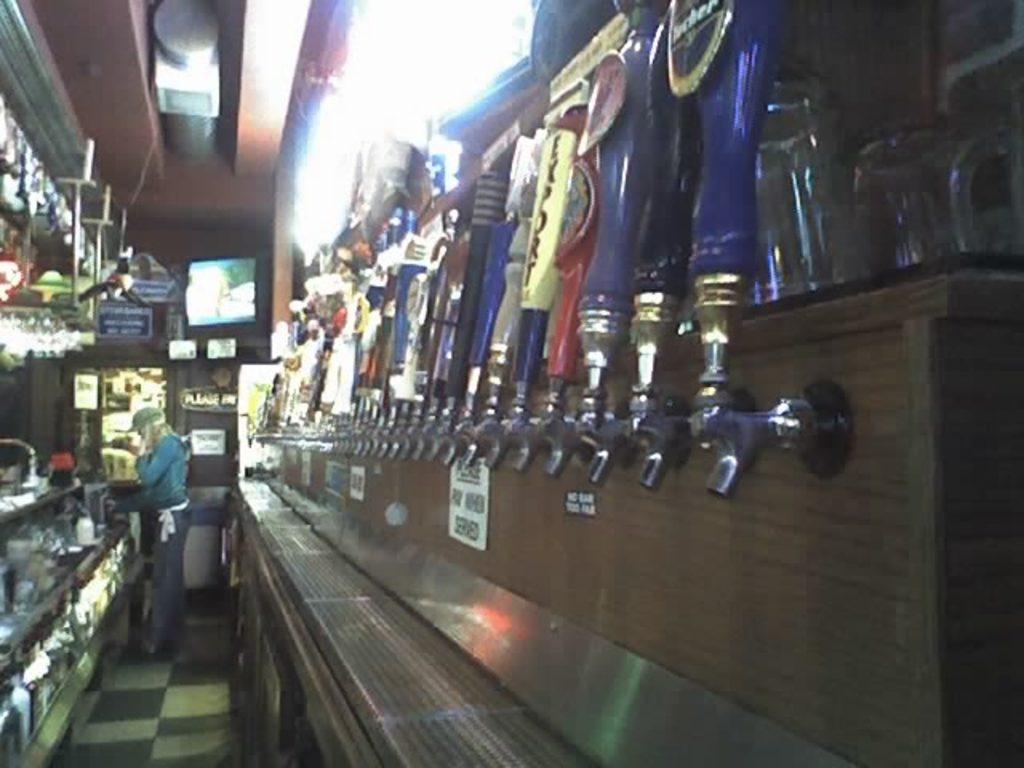Could you give a brief overview of what you see in this image? In this image there is a woman standing on the floor, on either side the women there are shelves in that shelves there are some objects, in the background there is a monitor. 